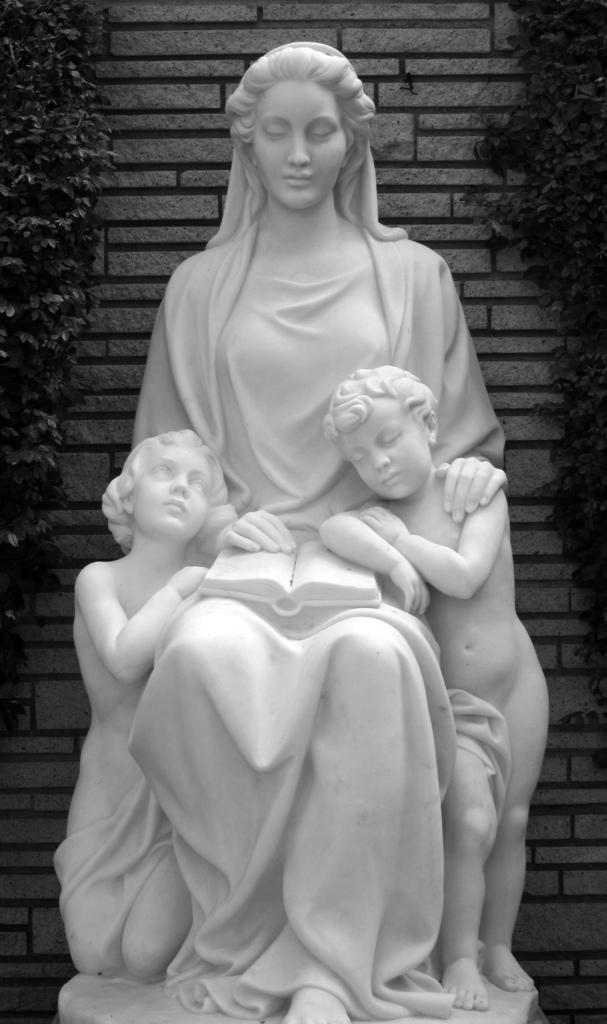In one or two sentences, can you explain what this image depicts? This is a black and white image and in the center we can see a statue. In the background, there is a wall and we can see trees. 